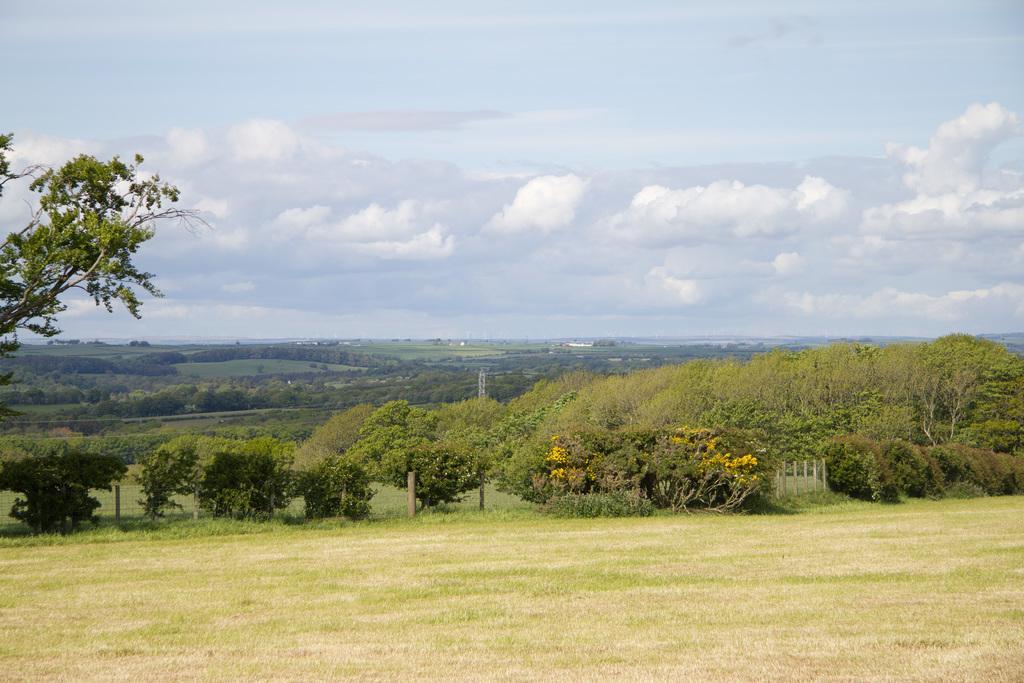In one or two sentences, can you explain what this image depicts? In this picture we can see the grass, trees and some rocks. 